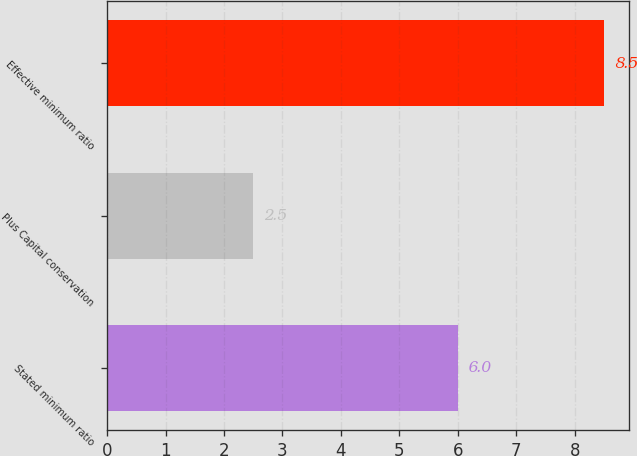Convert chart. <chart><loc_0><loc_0><loc_500><loc_500><bar_chart><fcel>Stated minimum ratio<fcel>Plus Capital conservation<fcel>Effective minimum ratio<nl><fcel>6<fcel>2.5<fcel>8.5<nl></chart> 